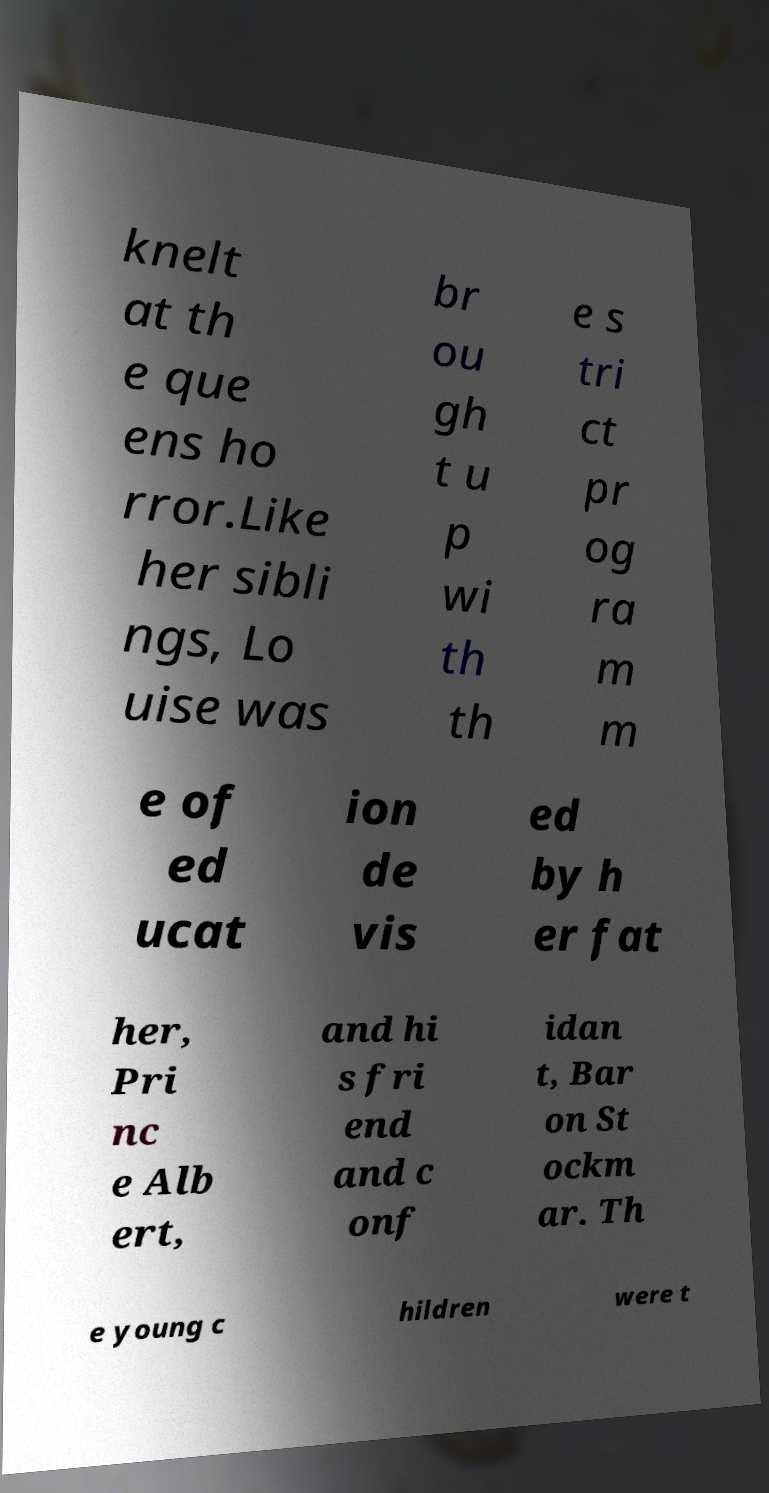Please read and relay the text visible in this image. What does it say? knelt at th e que ens ho rror.Like her sibli ngs, Lo uise was br ou gh t u p wi th th e s tri ct pr og ra m m e of ed ucat ion de vis ed by h er fat her, Pri nc e Alb ert, and hi s fri end and c onf idan t, Bar on St ockm ar. Th e young c hildren were t 